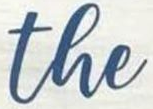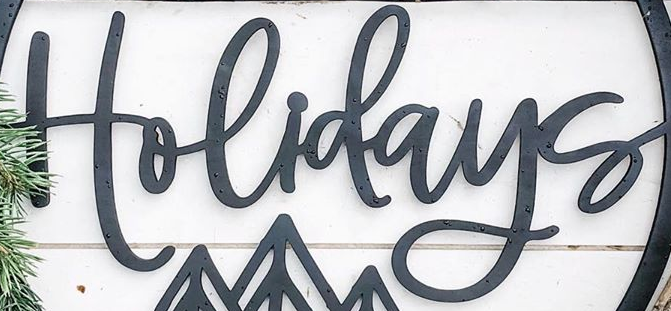Identify the words shown in these images in order, separated by a semicolon. the; Holidays 